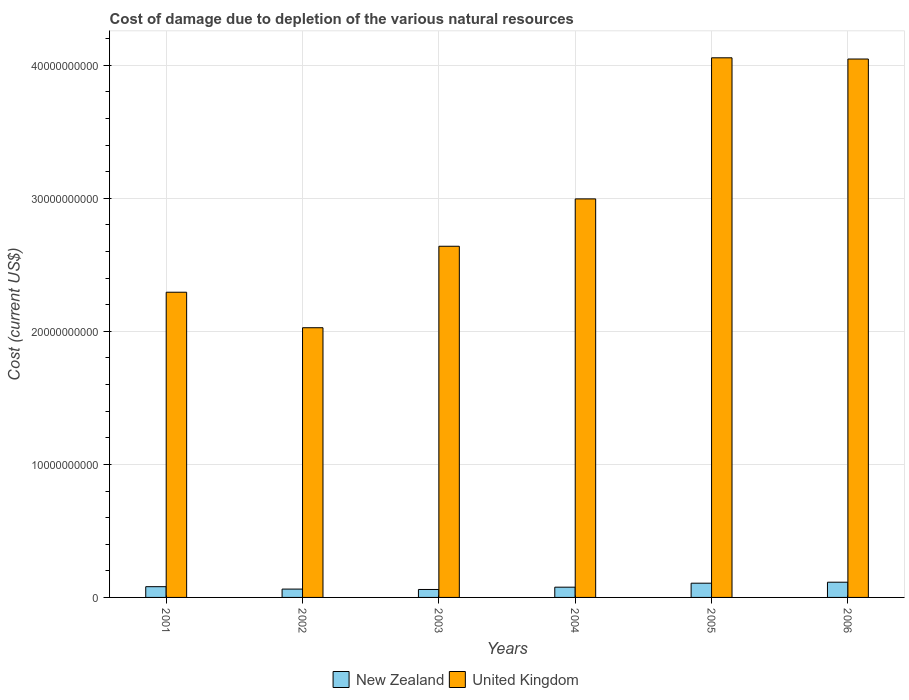How many groups of bars are there?
Keep it short and to the point. 6. Are the number of bars per tick equal to the number of legend labels?
Your response must be concise. Yes. Are the number of bars on each tick of the X-axis equal?
Provide a succinct answer. Yes. How many bars are there on the 4th tick from the left?
Provide a succinct answer. 2. How many bars are there on the 5th tick from the right?
Keep it short and to the point. 2. What is the label of the 1st group of bars from the left?
Offer a very short reply. 2001. What is the cost of damage caused due to the depletion of various natural resources in New Zealand in 2003?
Keep it short and to the point. 5.98e+08. Across all years, what is the maximum cost of damage caused due to the depletion of various natural resources in United Kingdom?
Your answer should be very brief. 4.06e+1. Across all years, what is the minimum cost of damage caused due to the depletion of various natural resources in New Zealand?
Your answer should be very brief. 5.98e+08. In which year was the cost of damage caused due to the depletion of various natural resources in United Kingdom maximum?
Make the answer very short. 2005. In which year was the cost of damage caused due to the depletion of various natural resources in New Zealand minimum?
Ensure brevity in your answer.  2003. What is the total cost of damage caused due to the depletion of various natural resources in United Kingdom in the graph?
Your answer should be compact. 1.81e+11. What is the difference between the cost of damage caused due to the depletion of various natural resources in New Zealand in 2001 and that in 2002?
Provide a succinct answer. 1.81e+08. What is the difference between the cost of damage caused due to the depletion of various natural resources in New Zealand in 2006 and the cost of damage caused due to the depletion of various natural resources in United Kingdom in 2004?
Ensure brevity in your answer.  -2.88e+1. What is the average cost of damage caused due to the depletion of various natural resources in New Zealand per year?
Provide a succinct answer. 8.36e+08. In the year 2001, what is the difference between the cost of damage caused due to the depletion of various natural resources in New Zealand and cost of damage caused due to the depletion of various natural resources in United Kingdom?
Ensure brevity in your answer.  -2.21e+1. In how many years, is the cost of damage caused due to the depletion of various natural resources in United Kingdom greater than 38000000000 US$?
Provide a short and direct response. 2. What is the ratio of the cost of damage caused due to the depletion of various natural resources in New Zealand in 2005 to that in 2006?
Offer a terse response. 0.94. Is the cost of damage caused due to the depletion of various natural resources in New Zealand in 2002 less than that in 2006?
Your answer should be very brief. Yes. What is the difference between the highest and the second highest cost of damage caused due to the depletion of various natural resources in United Kingdom?
Offer a very short reply. 9.18e+07. What is the difference between the highest and the lowest cost of damage caused due to the depletion of various natural resources in United Kingdom?
Keep it short and to the point. 2.03e+1. In how many years, is the cost of damage caused due to the depletion of various natural resources in United Kingdom greater than the average cost of damage caused due to the depletion of various natural resources in United Kingdom taken over all years?
Your answer should be very brief. 2. Is the sum of the cost of damage caused due to the depletion of various natural resources in United Kingdom in 2003 and 2006 greater than the maximum cost of damage caused due to the depletion of various natural resources in New Zealand across all years?
Your answer should be compact. Yes. What does the 2nd bar from the left in 2004 represents?
Keep it short and to the point. United Kingdom. What does the 1st bar from the right in 2005 represents?
Keep it short and to the point. United Kingdom. How many bars are there?
Your answer should be very brief. 12. Are all the bars in the graph horizontal?
Keep it short and to the point. No. How many years are there in the graph?
Keep it short and to the point. 6. What is the difference between two consecutive major ticks on the Y-axis?
Provide a succinct answer. 1.00e+1. Does the graph contain grids?
Your answer should be very brief. Yes. What is the title of the graph?
Give a very brief answer. Cost of damage due to depletion of the various natural resources. What is the label or title of the X-axis?
Make the answer very short. Years. What is the label or title of the Y-axis?
Your answer should be compact. Cost (current US$). What is the Cost (current US$) in New Zealand in 2001?
Offer a very short reply. 8.08e+08. What is the Cost (current US$) in United Kingdom in 2001?
Offer a very short reply. 2.29e+1. What is the Cost (current US$) in New Zealand in 2002?
Give a very brief answer. 6.27e+08. What is the Cost (current US$) in United Kingdom in 2002?
Provide a succinct answer. 2.03e+1. What is the Cost (current US$) of New Zealand in 2003?
Give a very brief answer. 5.98e+08. What is the Cost (current US$) in United Kingdom in 2003?
Offer a terse response. 2.64e+1. What is the Cost (current US$) in New Zealand in 2004?
Your response must be concise. 7.71e+08. What is the Cost (current US$) of United Kingdom in 2004?
Your answer should be very brief. 3.00e+1. What is the Cost (current US$) of New Zealand in 2005?
Keep it short and to the point. 1.07e+09. What is the Cost (current US$) in United Kingdom in 2005?
Provide a short and direct response. 4.06e+1. What is the Cost (current US$) in New Zealand in 2006?
Provide a succinct answer. 1.14e+09. What is the Cost (current US$) in United Kingdom in 2006?
Ensure brevity in your answer.  4.05e+1. Across all years, what is the maximum Cost (current US$) in New Zealand?
Keep it short and to the point. 1.14e+09. Across all years, what is the maximum Cost (current US$) in United Kingdom?
Give a very brief answer. 4.06e+1. Across all years, what is the minimum Cost (current US$) of New Zealand?
Keep it short and to the point. 5.98e+08. Across all years, what is the minimum Cost (current US$) in United Kingdom?
Offer a terse response. 2.03e+1. What is the total Cost (current US$) in New Zealand in the graph?
Provide a short and direct response. 5.02e+09. What is the total Cost (current US$) in United Kingdom in the graph?
Your answer should be very brief. 1.81e+11. What is the difference between the Cost (current US$) of New Zealand in 2001 and that in 2002?
Provide a short and direct response. 1.81e+08. What is the difference between the Cost (current US$) in United Kingdom in 2001 and that in 2002?
Make the answer very short. 2.67e+09. What is the difference between the Cost (current US$) in New Zealand in 2001 and that in 2003?
Your answer should be very brief. 2.11e+08. What is the difference between the Cost (current US$) in United Kingdom in 2001 and that in 2003?
Your response must be concise. -3.45e+09. What is the difference between the Cost (current US$) in New Zealand in 2001 and that in 2004?
Your response must be concise. 3.76e+07. What is the difference between the Cost (current US$) of United Kingdom in 2001 and that in 2004?
Your response must be concise. -7.02e+09. What is the difference between the Cost (current US$) in New Zealand in 2001 and that in 2005?
Your answer should be compact. -2.62e+08. What is the difference between the Cost (current US$) in United Kingdom in 2001 and that in 2005?
Your answer should be compact. -1.76e+1. What is the difference between the Cost (current US$) of New Zealand in 2001 and that in 2006?
Your response must be concise. -3.35e+08. What is the difference between the Cost (current US$) in United Kingdom in 2001 and that in 2006?
Make the answer very short. -1.75e+1. What is the difference between the Cost (current US$) of New Zealand in 2002 and that in 2003?
Provide a short and direct response. 2.94e+07. What is the difference between the Cost (current US$) of United Kingdom in 2002 and that in 2003?
Keep it short and to the point. -6.12e+09. What is the difference between the Cost (current US$) of New Zealand in 2002 and that in 2004?
Provide a succinct answer. -1.44e+08. What is the difference between the Cost (current US$) in United Kingdom in 2002 and that in 2004?
Provide a succinct answer. -9.69e+09. What is the difference between the Cost (current US$) of New Zealand in 2002 and that in 2005?
Give a very brief answer. -4.43e+08. What is the difference between the Cost (current US$) in United Kingdom in 2002 and that in 2005?
Provide a short and direct response. -2.03e+1. What is the difference between the Cost (current US$) in New Zealand in 2002 and that in 2006?
Offer a very short reply. -5.17e+08. What is the difference between the Cost (current US$) in United Kingdom in 2002 and that in 2006?
Offer a very short reply. -2.02e+1. What is the difference between the Cost (current US$) of New Zealand in 2003 and that in 2004?
Provide a short and direct response. -1.73e+08. What is the difference between the Cost (current US$) of United Kingdom in 2003 and that in 2004?
Keep it short and to the point. -3.56e+09. What is the difference between the Cost (current US$) in New Zealand in 2003 and that in 2005?
Make the answer very short. -4.72e+08. What is the difference between the Cost (current US$) in United Kingdom in 2003 and that in 2005?
Offer a very short reply. -1.42e+1. What is the difference between the Cost (current US$) of New Zealand in 2003 and that in 2006?
Your answer should be compact. -5.46e+08. What is the difference between the Cost (current US$) of United Kingdom in 2003 and that in 2006?
Offer a terse response. -1.41e+1. What is the difference between the Cost (current US$) in New Zealand in 2004 and that in 2005?
Offer a very short reply. -2.99e+08. What is the difference between the Cost (current US$) of United Kingdom in 2004 and that in 2005?
Make the answer very short. -1.06e+1. What is the difference between the Cost (current US$) in New Zealand in 2004 and that in 2006?
Keep it short and to the point. -3.73e+08. What is the difference between the Cost (current US$) in United Kingdom in 2004 and that in 2006?
Keep it short and to the point. -1.05e+1. What is the difference between the Cost (current US$) in New Zealand in 2005 and that in 2006?
Provide a short and direct response. -7.36e+07. What is the difference between the Cost (current US$) in United Kingdom in 2005 and that in 2006?
Make the answer very short. 9.18e+07. What is the difference between the Cost (current US$) in New Zealand in 2001 and the Cost (current US$) in United Kingdom in 2002?
Provide a succinct answer. -1.95e+1. What is the difference between the Cost (current US$) of New Zealand in 2001 and the Cost (current US$) of United Kingdom in 2003?
Provide a short and direct response. -2.56e+1. What is the difference between the Cost (current US$) of New Zealand in 2001 and the Cost (current US$) of United Kingdom in 2004?
Offer a very short reply. -2.92e+1. What is the difference between the Cost (current US$) in New Zealand in 2001 and the Cost (current US$) in United Kingdom in 2005?
Provide a succinct answer. -3.98e+1. What is the difference between the Cost (current US$) of New Zealand in 2001 and the Cost (current US$) of United Kingdom in 2006?
Provide a short and direct response. -3.97e+1. What is the difference between the Cost (current US$) of New Zealand in 2002 and the Cost (current US$) of United Kingdom in 2003?
Your answer should be very brief. -2.58e+1. What is the difference between the Cost (current US$) of New Zealand in 2002 and the Cost (current US$) of United Kingdom in 2004?
Make the answer very short. -2.93e+1. What is the difference between the Cost (current US$) of New Zealand in 2002 and the Cost (current US$) of United Kingdom in 2005?
Your answer should be compact. -3.99e+1. What is the difference between the Cost (current US$) in New Zealand in 2002 and the Cost (current US$) in United Kingdom in 2006?
Make the answer very short. -3.98e+1. What is the difference between the Cost (current US$) of New Zealand in 2003 and the Cost (current US$) of United Kingdom in 2004?
Offer a very short reply. -2.94e+1. What is the difference between the Cost (current US$) in New Zealand in 2003 and the Cost (current US$) in United Kingdom in 2005?
Your answer should be compact. -4.00e+1. What is the difference between the Cost (current US$) of New Zealand in 2003 and the Cost (current US$) of United Kingdom in 2006?
Provide a succinct answer. -3.99e+1. What is the difference between the Cost (current US$) of New Zealand in 2004 and the Cost (current US$) of United Kingdom in 2005?
Keep it short and to the point. -3.98e+1. What is the difference between the Cost (current US$) of New Zealand in 2004 and the Cost (current US$) of United Kingdom in 2006?
Ensure brevity in your answer.  -3.97e+1. What is the difference between the Cost (current US$) in New Zealand in 2005 and the Cost (current US$) in United Kingdom in 2006?
Offer a terse response. -3.94e+1. What is the average Cost (current US$) of New Zealand per year?
Make the answer very short. 8.36e+08. What is the average Cost (current US$) of United Kingdom per year?
Provide a short and direct response. 3.01e+1. In the year 2001, what is the difference between the Cost (current US$) in New Zealand and Cost (current US$) in United Kingdom?
Your response must be concise. -2.21e+1. In the year 2002, what is the difference between the Cost (current US$) of New Zealand and Cost (current US$) of United Kingdom?
Keep it short and to the point. -1.96e+1. In the year 2003, what is the difference between the Cost (current US$) of New Zealand and Cost (current US$) of United Kingdom?
Keep it short and to the point. -2.58e+1. In the year 2004, what is the difference between the Cost (current US$) of New Zealand and Cost (current US$) of United Kingdom?
Keep it short and to the point. -2.92e+1. In the year 2005, what is the difference between the Cost (current US$) of New Zealand and Cost (current US$) of United Kingdom?
Give a very brief answer. -3.95e+1. In the year 2006, what is the difference between the Cost (current US$) in New Zealand and Cost (current US$) in United Kingdom?
Your answer should be compact. -3.93e+1. What is the ratio of the Cost (current US$) in New Zealand in 2001 to that in 2002?
Your answer should be compact. 1.29. What is the ratio of the Cost (current US$) of United Kingdom in 2001 to that in 2002?
Give a very brief answer. 1.13. What is the ratio of the Cost (current US$) of New Zealand in 2001 to that in 2003?
Provide a succinct answer. 1.35. What is the ratio of the Cost (current US$) of United Kingdom in 2001 to that in 2003?
Your answer should be compact. 0.87. What is the ratio of the Cost (current US$) in New Zealand in 2001 to that in 2004?
Offer a terse response. 1.05. What is the ratio of the Cost (current US$) in United Kingdom in 2001 to that in 2004?
Offer a very short reply. 0.77. What is the ratio of the Cost (current US$) of New Zealand in 2001 to that in 2005?
Provide a short and direct response. 0.76. What is the ratio of the Cost (current US$) of United Kingdom in 2001 to that in 2005?
Give a very brief answer. 0.57. What is the ratio of the Cost (current US$) of New Zealand in 2001 to that in 2006?
Offer a very short reply. 0.71. What is the ratio of the Cost (current US$) in United Kingdom in 2001 to that in 2006?
Offer a terse response. 0.57. What is the ratio of the Cost (current US$) in New Zealand in 2002 to that in 2003?
Offer a very short reply. 1.05. What is the ratio of the Cost (current US$) of United Kingdom in 2002 to that in 2003?
Your answer should be compact. 0.77. What is the ratio of the Cost (current US$) of New Zealand in 2002 to that in 2004?
Make the answer very short. 0.81. What is the ratio of the Cost (current US$) of United Kingdom in 2002 to that in 2004?
Offer a terse response. 0.68. What is the ratio of the Cost (current US$) of New Zealand in 2002 to that in 2005?
Your response must be concise. 0.59. What is the ratio of the Cost (current US$) of United Kingdom in 2002 to that in 2005?
Provide a short and direct response. 0.5. What is the ratio of the Cost (current US$) of New Zealand in 2002 to that in 2006?
Offer a terse response. 0.55. What is the ratio of the Cost (current US$) of United Kingdom in 2002 to that in 2006?
Offer a very short reply. 0.5. What is the ratio of the Cost (current US$) of New Zealand in 2003 to that in 2004?
Ensure brevity in your answer.  0.78. What is the ratio of the Cost (current US$) of United Kingdom in 2003 to that in 2004?
Provide a succinct answer. 0.88. What is the ratio of the Cost (current US$) in New Zealand in 2003 to that in 2005?
Make the answer very short. 0.56. What is the ratio of the Cost (current US$) in United Kingdom in 2003 to that in 2005?
Offer a terse response. 0.65. What is the ratio of the Cost (current US$) of New Zealand in 2003 to that in 2006?
Offer a very short reply. 0.52. What is the ratio of the Cost (current US$) of United Kingdom in 2003 to that in 2006?
Provide a succinct answer. 0.65. What is the ratio of the Cost (current US$) in New Zealand in 2004 to that in 2005?
Provide a succinct answer. 0.72. What is the ratio of the Cost (current US$) in United Kingdom in 2004 to that in 2005?
Your response must be concise. 0.74. What is the ratio of the Cost (current US$) of New Zealand in 2004 to that in 2006?
Give a very brief answer. 0.67. What is the ratio of the Cost (current US$) of United Kingdom in 2004 to that in 2006?
Offer a terse response. 0.74. What is the ratio of the Cost (current US$) in New Zealand in 2005 to that in 2006?
Offer a very short reply. 0.94. What is the ratio of the Cost (current US$) in United Kingdom in 2005 to that in 2006?
Offer a terse response. 1. What is the difference between the highest and the second highest Cost (current US$) in New Zealand?
Provide a short and direct response. 7.36e+07. What is the difference between the highest and the second highest Cost (current US$) in United Kingdom?
Your response must be concise. 9.18e+07. What is the difference between the highest and the lowest Cost (current US$) in New Zealand?
Make the answer very short. 5.46e+08. What is the difference between the highest and the lowest Cost (current US$) of United Kingdom?
Offer a very short reply. 2.03e+1. 